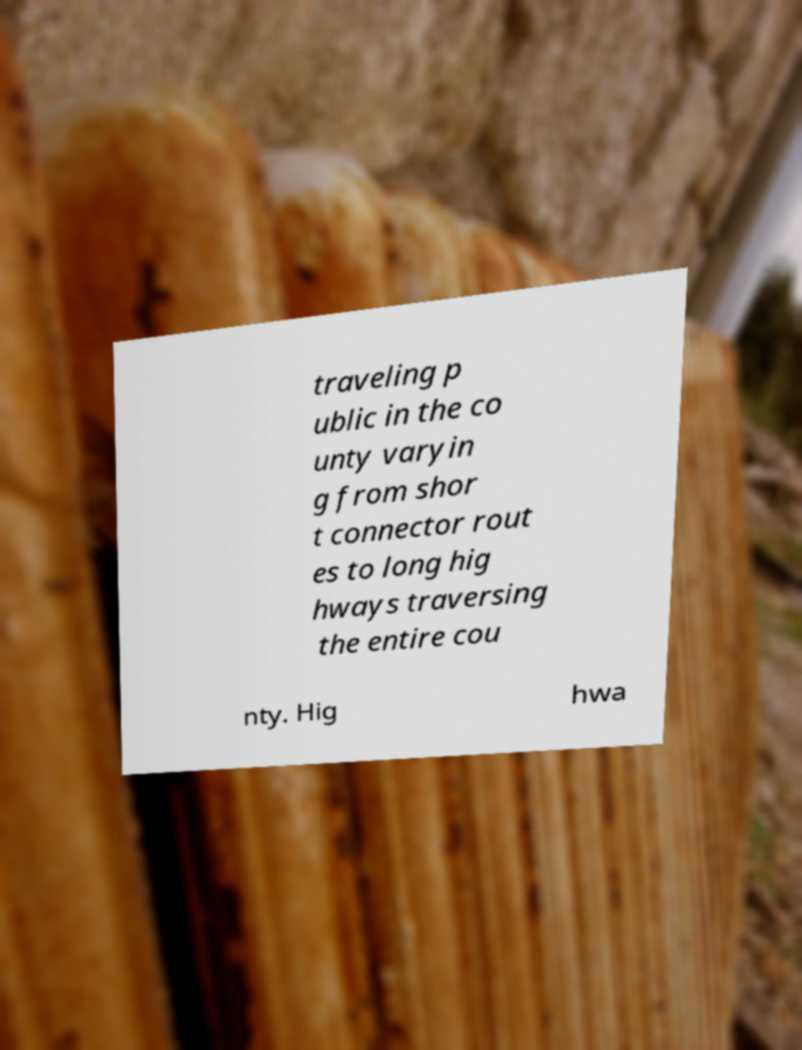Please identify and transcribe the text found in this image. traveling p ublic in the co unty varyin g from shor t connector rout es to long hig hways traversing the entire cou nty. Hig hwa 